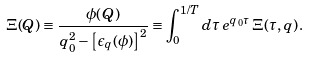Convert formula to latex. <formula><loc_0><loc_0><loc_500><loc_500>\Xi ( Q ) \equiv \frac { \phi ( Q ) } { q _ { 0 } ^ { 2 } - \left [ \epsilon _ { q } ( \phi ) \right ] ^ { 2 } } \equiv \int _ { 0 } ^ { 1 / T } d \tau \, e ^ { q _ { 0 } \tau } \, \Xi ( \tau , { q } ) \, .</formula> 